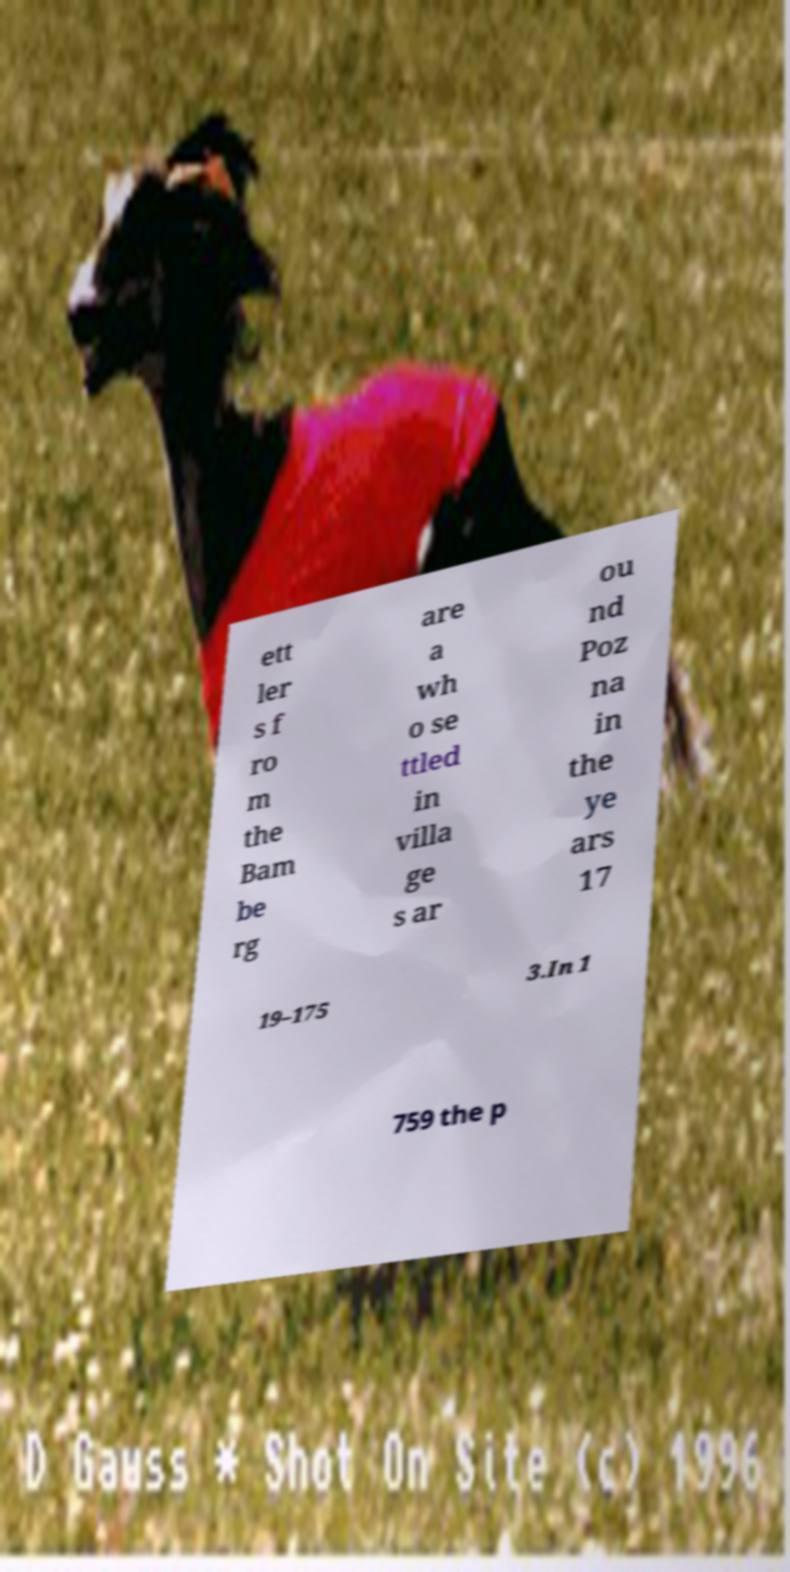For documentation purposes, I need the text within this image transcribed. Could you provide that? ett ler s f ro m the Bam be rg are a wh o se ttled in villa ge s ar ou nd Poz na in the ye ars 17 19–175 3.In 1 759 the p 